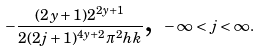Convert formula to latex. <formula><loc_0><loc_0><loc_500><loc_500>- \frac { ( 2 y + 1 ) 2 ^ { 2 y + 1 } } { 2 ( 2 j + 1 ) ^ { 4 y + 2 } \pi ^ { 2 } h k } \text {,} \ - \infty < j < \infty .</formula> 